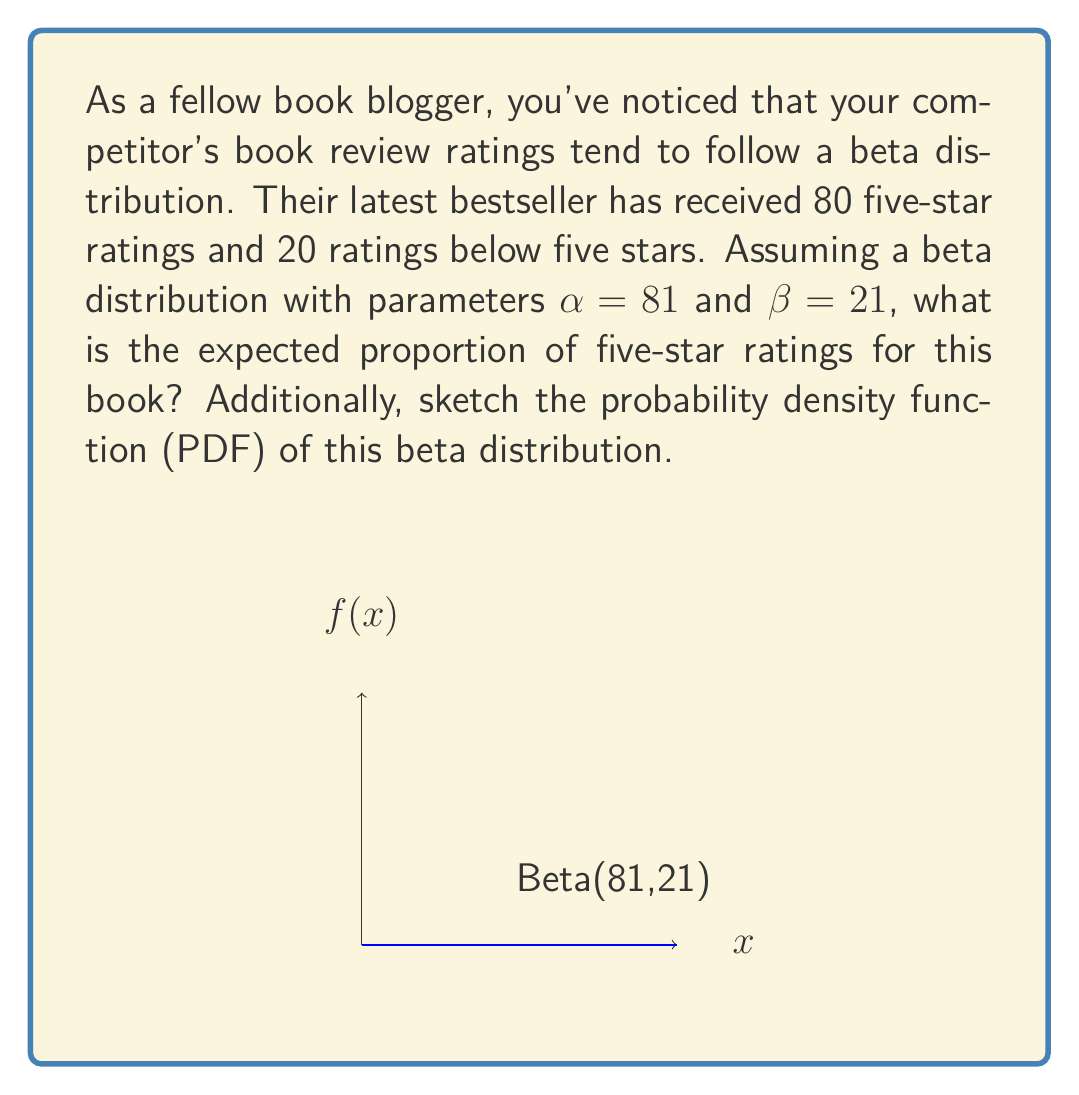Give your solution to this math problem. To solve this problem, we'll follow these steps:

1) The beta distribution is characterized by two shape parameters, $\alpha$ and $\beta$. In this case, $\alpha = 81$ and $\beta = 21$.

2) For a beta distribution, the expected value (mean) is given by the formula:

   $$E[X] = \frac{\alpha}{\alpha + \beta}$$

3) Substituting our values:

   $$E[X] = \frac{81}{81 + 21} = \frac{81}{102}$$

4) To simplify this fraction:
   
   $$\frac{81}{102} = \frac{81/3}{102/3} = \frac{27}{34} \approx 0.7941$$

5) This means that the expected proportion of five-star ratings is approximately 0.7941 or about 79.41%.

6) The probability density function (PDF) of the beta distribution is given by:

   $$f(x; \alpha, \beta) = \frac{x^{\alpha-1}(1-x)^{\beta-1}}{B(\alpha,\beta)}$$

   where $B(\alpha,\beta)$ is the beta function.

7) The graph provided in the question shows this PDF for Beta(81,21). The peak of the distribution is close to but slightly below 0.8, which aligns with our calculated expected value.
Answer: $\frac{27}{34}$ or approximately 0.7941 